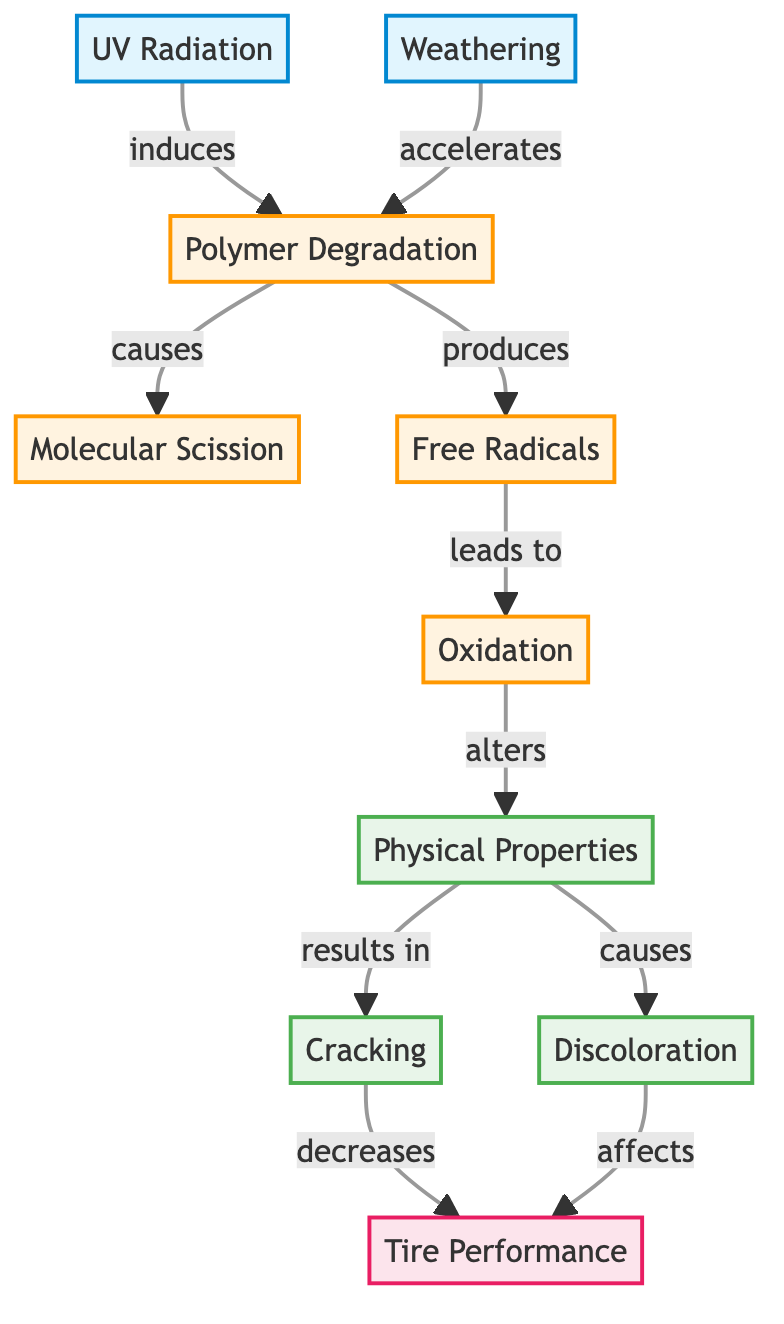What are the two environmental factors depicted in the diagram? The diagram lists UV Radiation and Weathering as the two environmental factors influencing tire polymer aging, identifiable as the first two nodes on the left.
Answer: UV Radiation, Weathering How many connections lead from Polymer Degradation? Polymer Degradation has two outgoing connections, specifically to Molecular Scission and Free Radicals, which can be counted directly from the diagram.
Answer: 2 What effect does Cracking have on Tire Performance? According to the diagram, Cracking decreases Tire Performance, as indicated by the directed edge leading from Cracking to Tire Performance.
Answer: decreases Which chemical process is produced as a result of Polymer Degradation? The diagram indicates that Free Radicals are produced as a result of Polymer Degradation, directly following that node in the flow.
Answer: Free Radicals What relationship exists between Weathering and Polymer Degradation? The diagram indicates that Weathering accelerates Polymer Degradation, as shown by the directed arrow linking the two nodes.
Answer: accelerates What happens to Physical Properties as a result of Oxidation? The diagram specifies that Oxidation alters Physical Properties, demonstrating a direct causal relationship shown by the arrow between Oxidation and Physical Properties.
Answer: alters How does Discoloration affect Tire Performance? Discoloration affects Tire Performance, as indicated in the diagram by the directed edge from Discoloration to Tire Performance.
Answer: affects What type of property results from the alteration of Physical Properties? According to the diagram, Cracking and Discoloration are the two physical properties resulting from the alteration of Physical Properties, both displayed as outcomes from that node.
Answer: Cracking, Discoloration What induces Polymer Degradation? UV Radiation induces Polymer Degradation in the diagram, as shown by the directed connection from UV Radiation leading to Polymer Degradation.
Answer: induces 